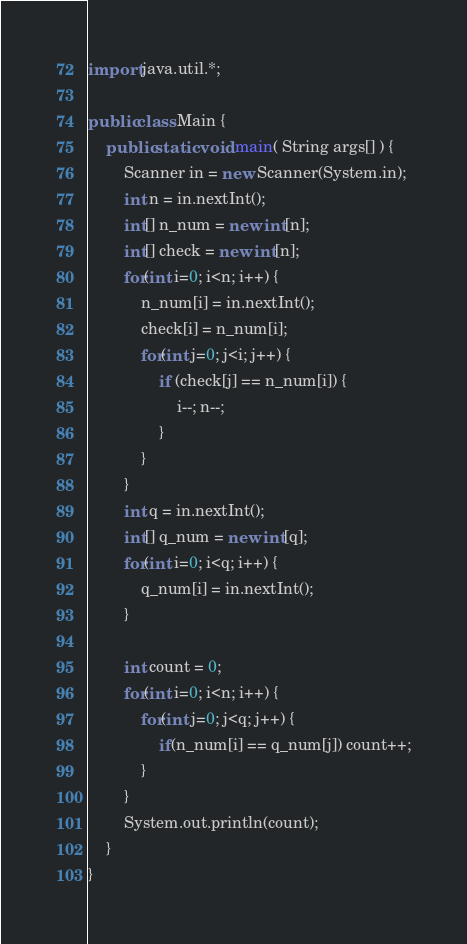<code> <loc_0><loc_0><loc_500><loc_500><_Java_>import java.util.*;

public class Main {
	public static void main( String args[] ) {
		Scanner in = new Scanner(System.in);
		int n = in.nextInt();
		int[] n_num = new int[n];
		int[] check = new int[n];
		for(int i=0; i<n; i++) {
			n_num[i] = in.nextInt();
			check[i] = n_num[i];
			for(int j=0; j<i; j++) {
				if (check[j] == n_num[i]) {
					i--; n--;
				}
			}
		}
		int q = in.nextInt();
		int[] q_num = new int[q];
		for(int i=0; i<q; i++) {
			q_num[i] = in.nextInt();
		}
		
		int count = 0;
		for(int i=0; i<n; i++) {
			for(int j=0; j<q; j++) {
				if(n_num[i] == q_num[j]) count++;
			}
		}
		System.out.println(count);
	}
}</code> 